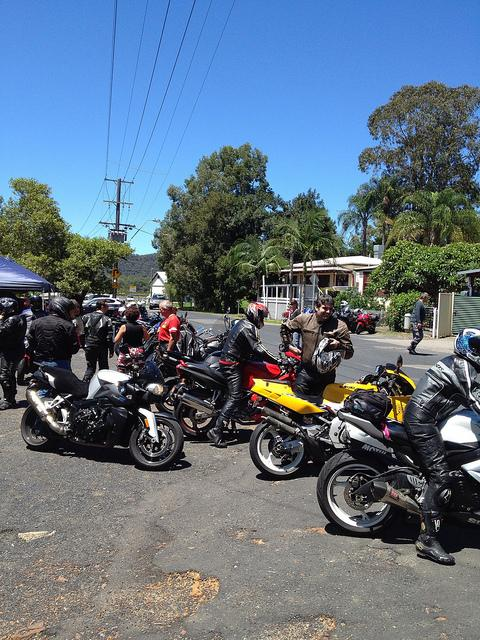What type weather is typical here?

Choices:
A) tundra
B) freezing
C) all
D) tropical tropical 